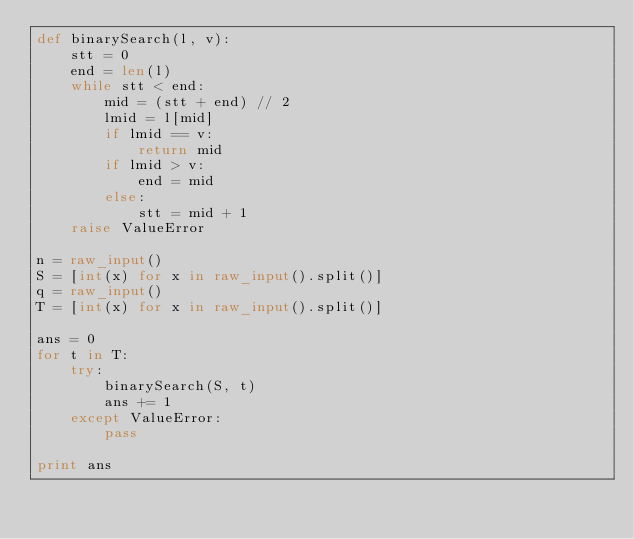Convert code to text. <code><loc_0><loc_0><loc_500><loc_500><_Python_>def binarySearch(l, v):
    stt = 0
    end = len(l)
    while stt < end:
        mid = (stt + end) // 2
        lmid = l[mid]
        if lmid == v:
            return mid
        if lmid > v:
            end = mid
        else:
            stt = mid + 1
    raise ValueError

n = raw_input()
S = [int(x) for x in raw_input().split()]
q = raw_input()
T = [int(x) for x in raw_input().split()]

ans = 0
for t in T:
    try:
        binarySearch(S, t)
        ans += 1
    except ValueError:
        pass

print ans</code> 